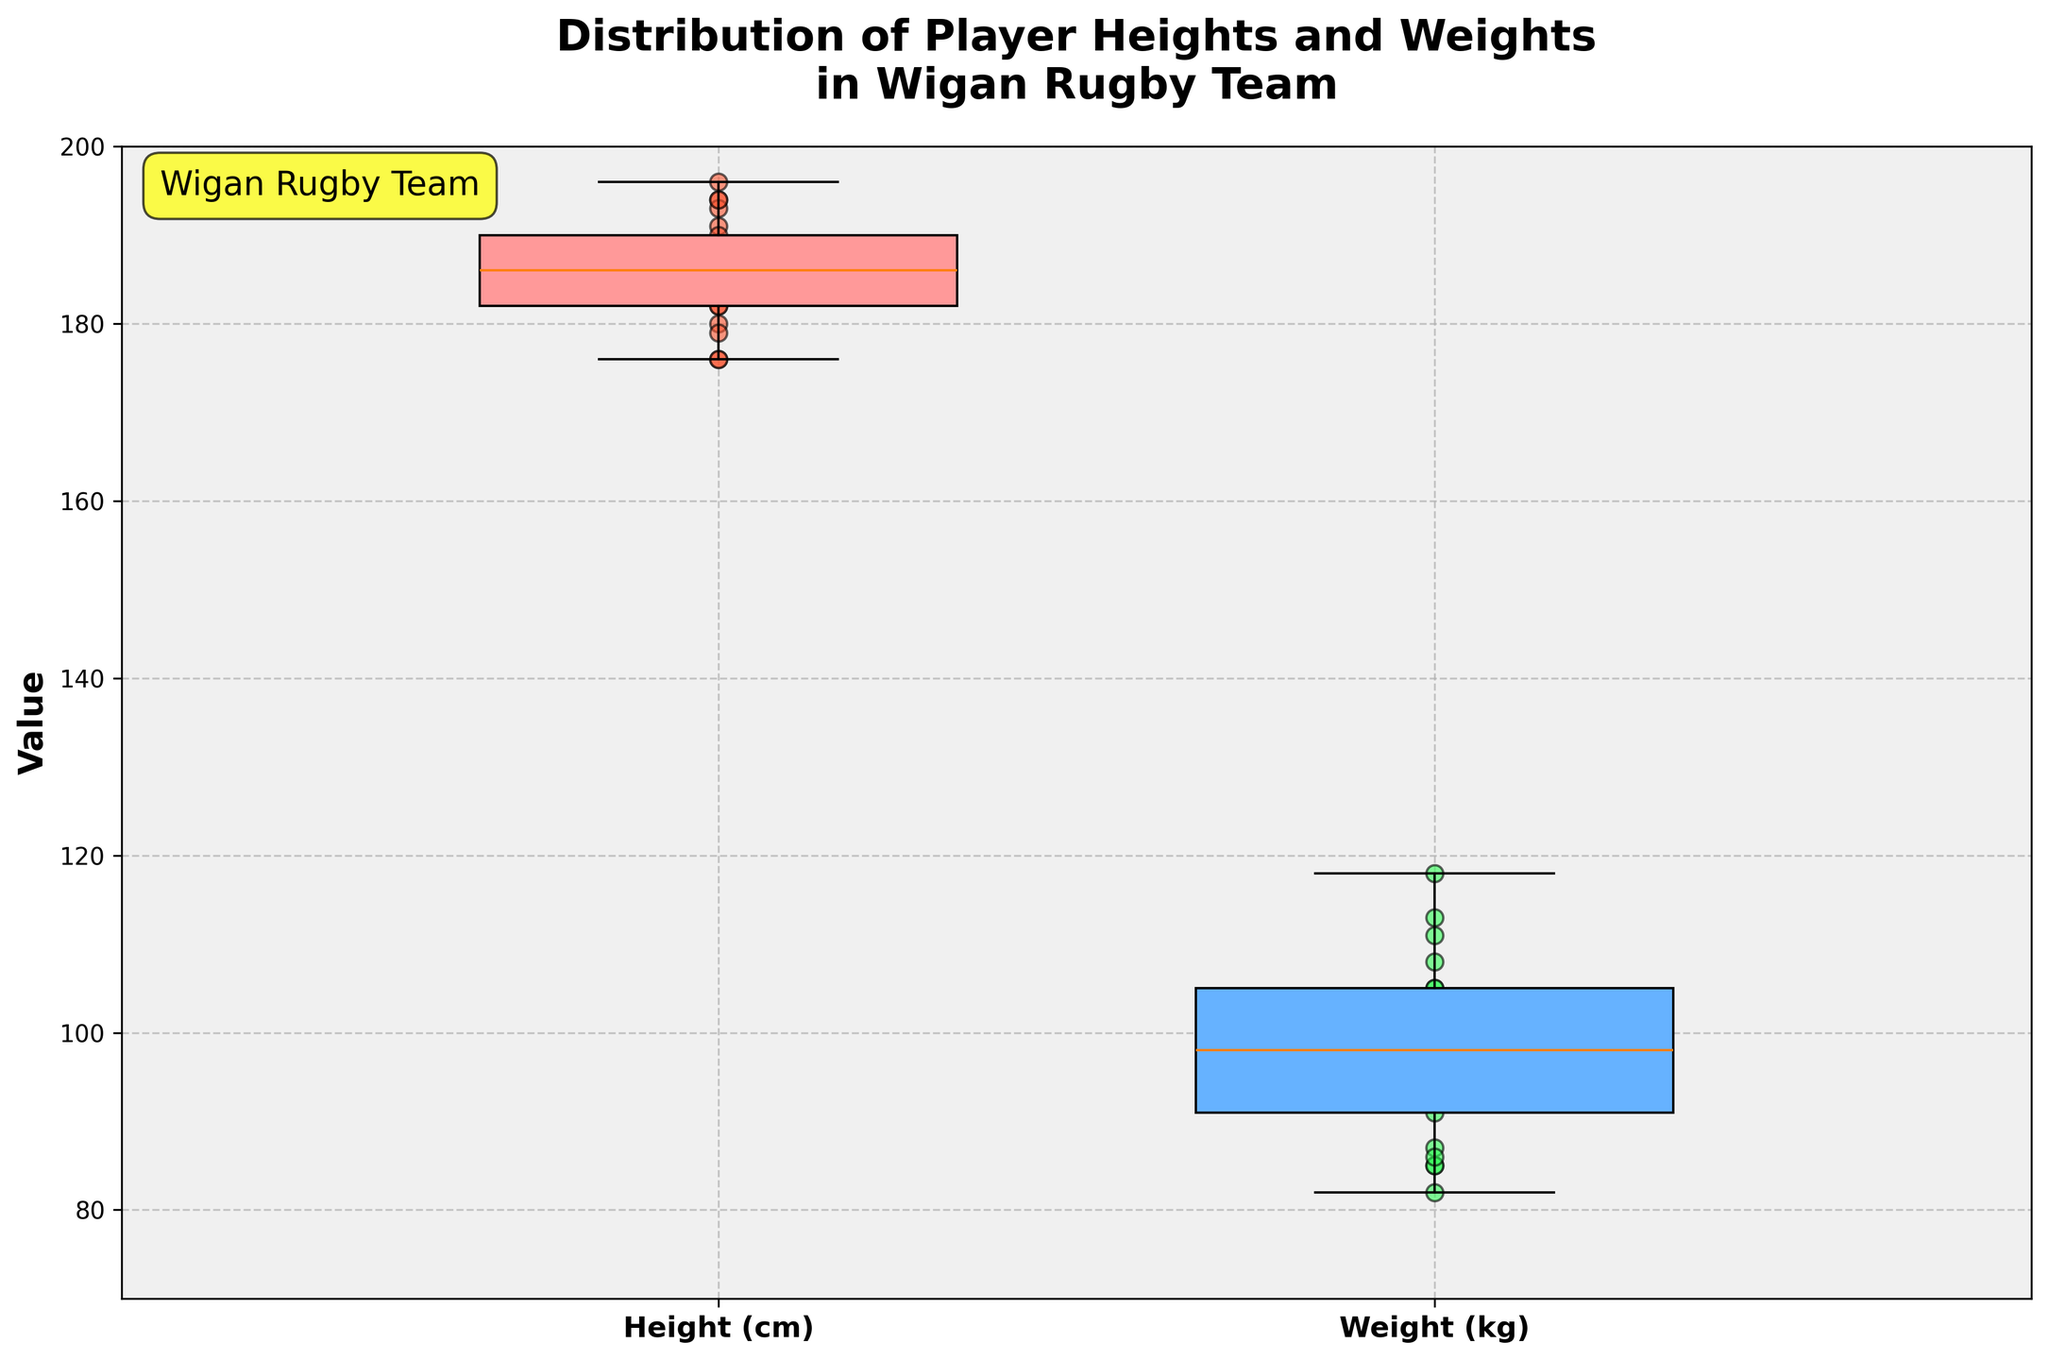What's the title of the plot? The title of the plot is written at the top of the figure in bold font. It states the overall subject of the plot, which is "Distribution of Player Heights and Weights in Wigan Rugby Team".
Answer: Distribution of Player Heights and Weights in Wigan Rugby Team How many different data sets are represented in the box plot? The box plot shows two different data sets. One for player heights and another for player weights, as indicated by the labels on the x-axis.
Answer: 2 What is the color of the box plot for player weights? The color of the box plot for player weights is discernibly different from the one for player heights. This can be seen in the figure where the weights box plot is colored with a bluish tint, suggesting a more distinct color setting.
Answer: Blue What's the median height of the Wigan rugby team players? The median height can be observed from the line inside the height (0.7 position) box plot. The median height line appears to be at approximately 186 cm.
Answer: 186 cm What is the height range covered by the middle 50% of the data? The height range covered by the middle 50% is between the lower quartile and the upper quartile of the heights box plot. These seem to be approximately from 182 cm to 190 cm.
Answer: 182 cm to 190 cm How does the median weight compare to the median height in this plot? By examining the lines within each box plot for height and weight, we can see that the median lines fall at different values. The median weight is higher than the median height. The median weight appears to be around 102 kg.
Answer: Median weight is higher than median height Which player represents the highest weight and what is it? By checking the scatter points in the weights section (1.3 position) above the box plot, we see that the highest point is marked at approximately 118 kg. This point corresponds to George Burgess, whose weight is listed as 118 kg.
Answer: George Burgess, 118 kg Are there any outliers in the player heights or weights? Outliers are typically represented by individual points outside the whiskers of a box plot. In this figure, there are no points that lie outside the whiskers of either the height or weight box plots, meaning no outliers are present.
Answer: No What's the interquartile range (IQR) for player weights? The interquartile range for player weights is calculated by subtracting the value at the lower quartile from the value at the upper quartile. According to the visual, these values appear to be approximately 95 kg and 108 kg respectively. So, IQR = 108 kg - 95 kg.
Answer: 13 kg What is the purpose of adding scatter points to the box plot in this figure? Scatter points allow us to see individual data points superimposed on the summarized box plot data, providing a more detailed view of each player’s height and weight within the distribution.
Answer: To see individual data points 